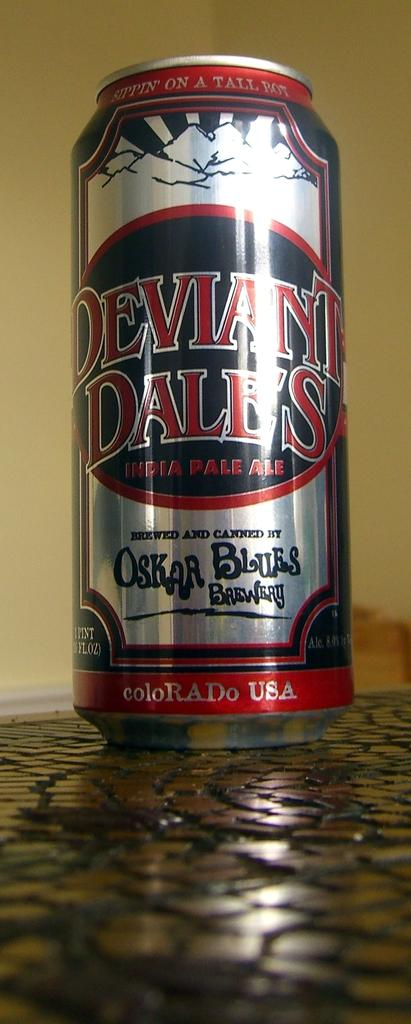<image>
Describe the image concisely. a can of Deviant Dale's India Pale Ale on a table 